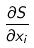Convert formula to latex. <formula><loc_0><loc_0><loc_500><loc_500>\frac { \partial S } { \partial x _ { i } }</formula> 